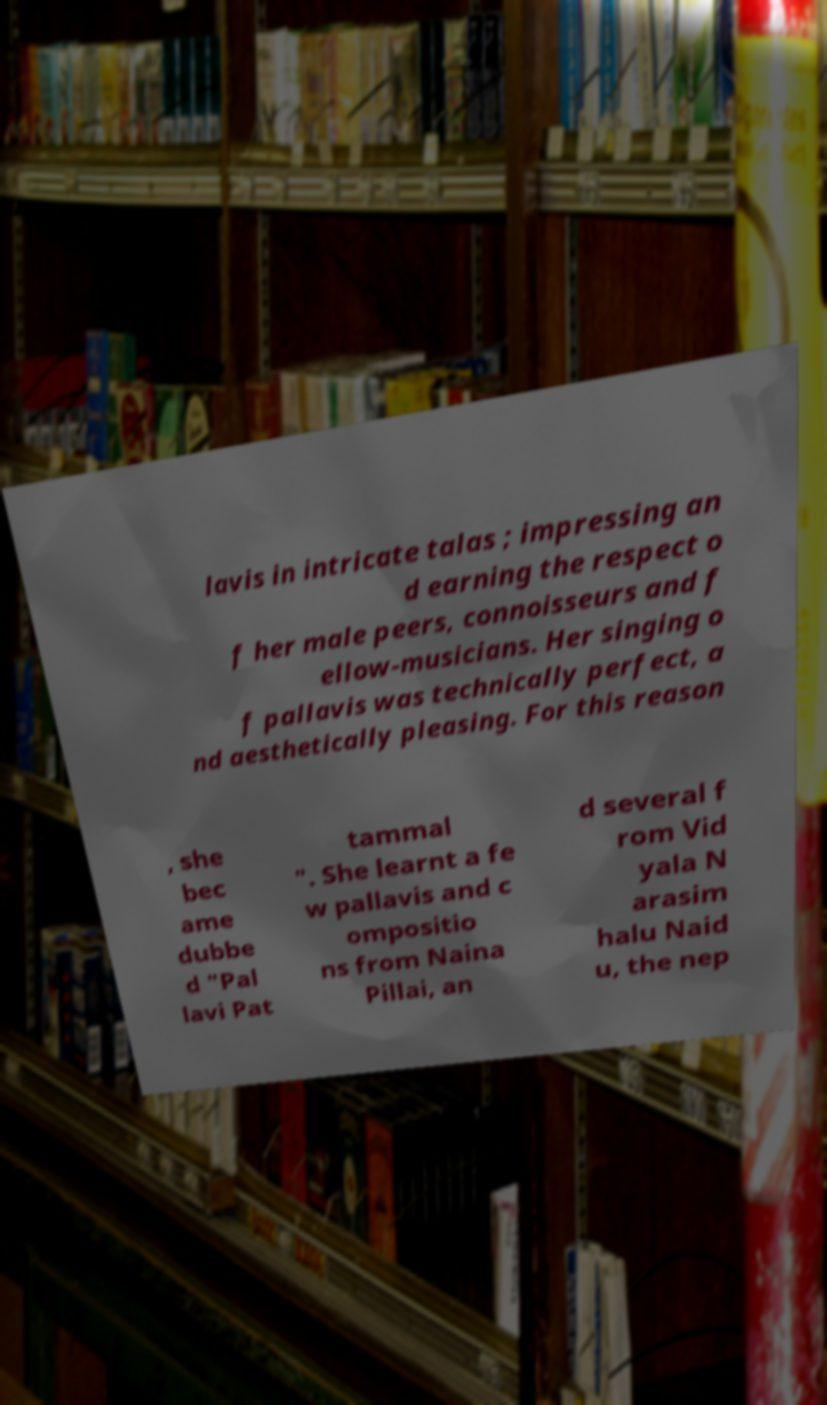Please read and relay the text visible in this image. What does it say? lavis in intricate talas ; impressing an d earning the respect o f her male peers, connoisseurs and f ellow-musicians. Her singing o f pallavis was technically perfect, a nd aesthetically pleasing. For this reason , she bec ame dubbe d "Pal lavi Pat tammal ". She learnt a fe w pallavis and c ompositio ns from Naina Pillai, an d several f rom Vid yala N arasim halu Naid u, the nep 